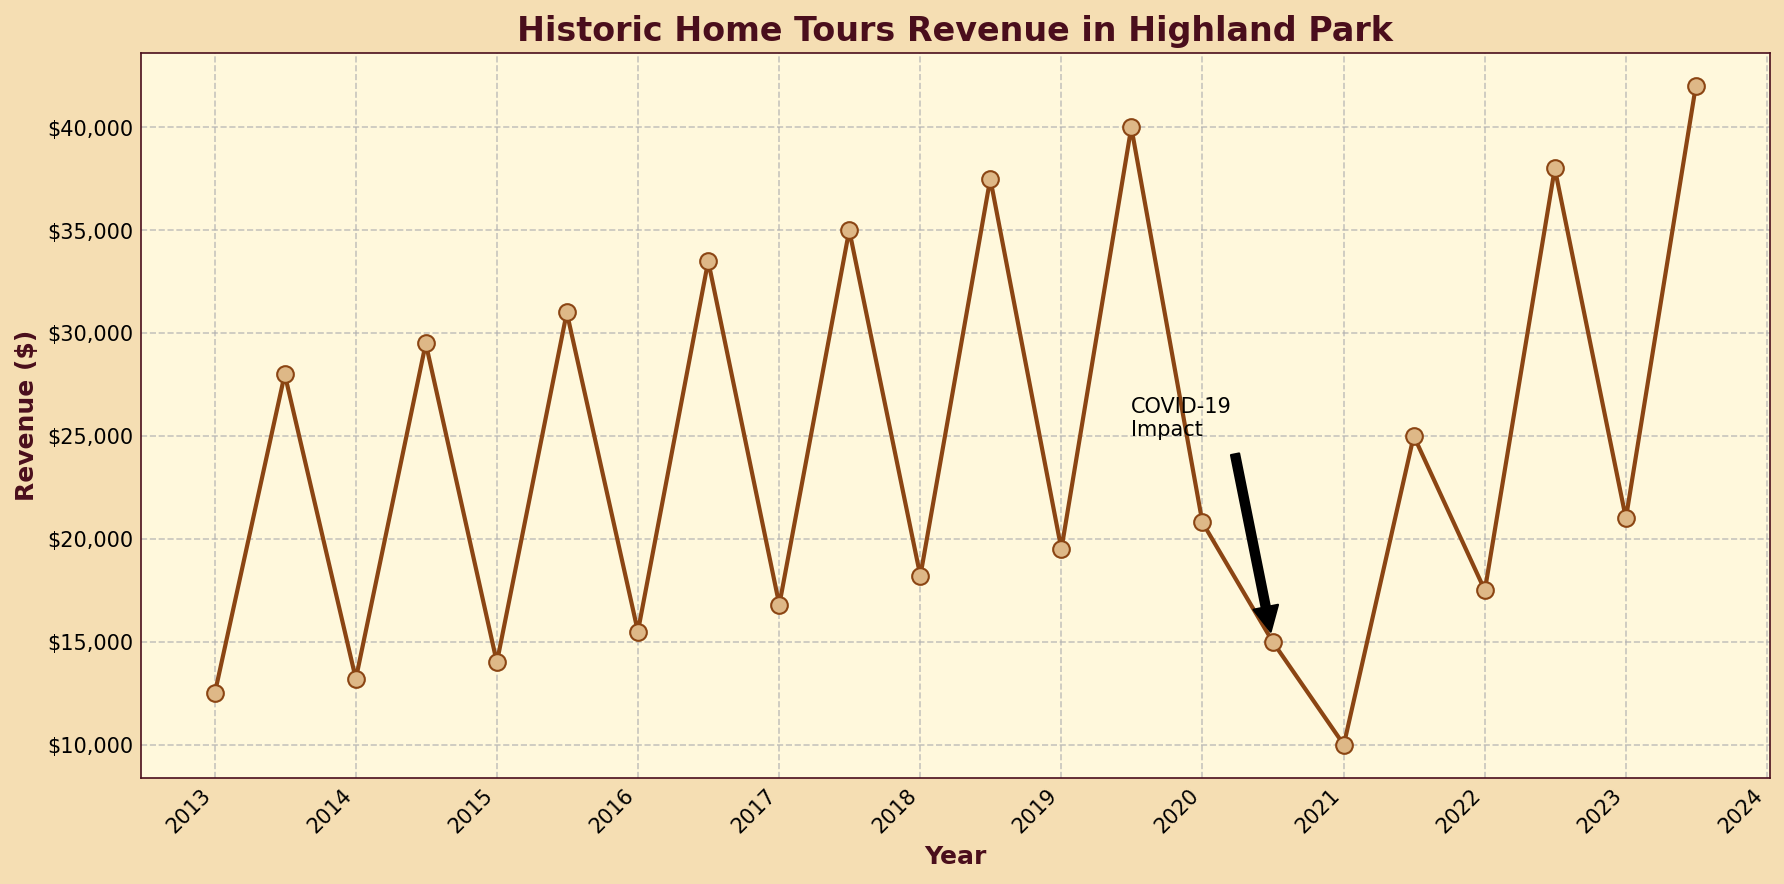Which month across the decade generally has higher revenue, January or July? By observing the chart, July is consistently higher compared to January each year. For example, in 2013, January’s revenue is $12,500, while July’s is $28,000. This pattern holds true for most years shown in the chart.
Answer: July What was the impact of COVID-19 on the revenue in July 2020 compared to July 2019? The revenue in July 2020 dropped to $15,000 compared to $40,000 in July 2019. To find the impact, we subtract the revenue of July 2020 from July 2019: $40,000 - $15,000 = $25,000. This indicates a significant drop due to the pandemic.
Answer: $25,000 decrease What is the average revenue for January over the entire decade? To find the average, sum up the January revenues and divide by the number of years (2013-2023). The revenue for January each year is: $12,500, $13,200, $14,000, $15,500, $16,800, $18,200, $19,500, $20,800, $10,000, $17,500, $21,000. Summing these gives $178,000 and dividing by 11 years results in $16,181.82.
Answer: $16,181.82 What year saw the highest revenue in July and what was the revenue? By examining the chart, the highest peak in July occurs in 2023 with a revenue of $42,000.
Answer: 2023, $42,000 Compare the revenue trend before and after the pandemic (2020). What can be observed? Before the pandemic (2013-2019), the revenue generally increased each year. Post-2020, there was a sharp decline in 2021, but revenue started to recover again in 2022 and peaked again in 2023 with increasing trends in both January and July.
Answer: Steady increase before 2020, sharp decline in 2021, recovering in 2022-2023 What is the total revenue generated in July from 2013 to 2023? To find the total revenue for July, sum the revenues of July each year: $28,000, $29,500, $31,000, $33,500, $35,000, $37,500, $40,000, $15,000, $25,000, $38,000, and $42,000. This results in $354,500.
Answer: $354,500 How much did the revenue increase from January 2022 to January 2023? Revenue in January 2022 was $17,500 and in January 2023, it was $21,000. The increase is calculated by subtracting the revenue in January 2022 from January 2023: $21,000 - $17,500 = $3,500.
Answer: $3,500 During which month and year did the revenue hit the lowest point over the decade, and what was the revenue? The lowest point on the chart is in January 2021 with a revenue of $10,000.
Answer: January 2021, $10,000 